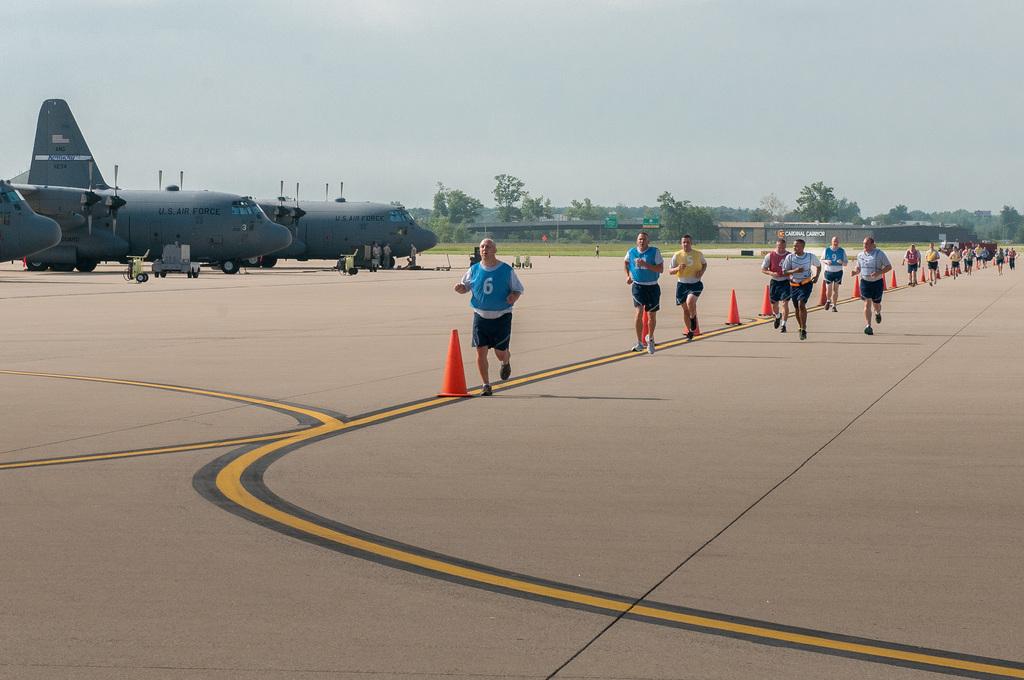What number is the man's jersey?
Offer a very short reply. 6. What branch of the military are the planes from?
Give a very brief answer. Us air force. 